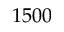<formula> <loc_0><loc_0><loc_500><loc_500>1 5 0 0</formula> 